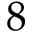<formula> <loc_0><loc_0><loc_500><loc_500>8</formula> 